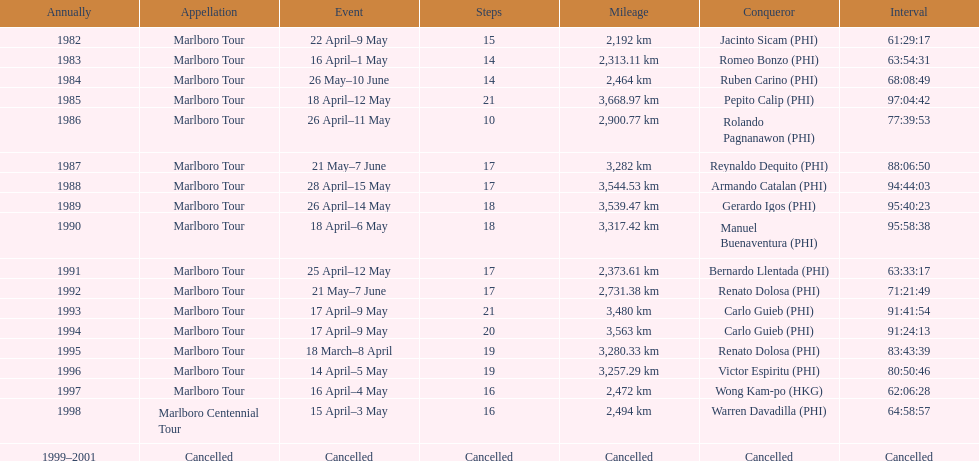How long did it take warren davadilla to complete the 1998 marlboro centennial tour? 64:58:57. 